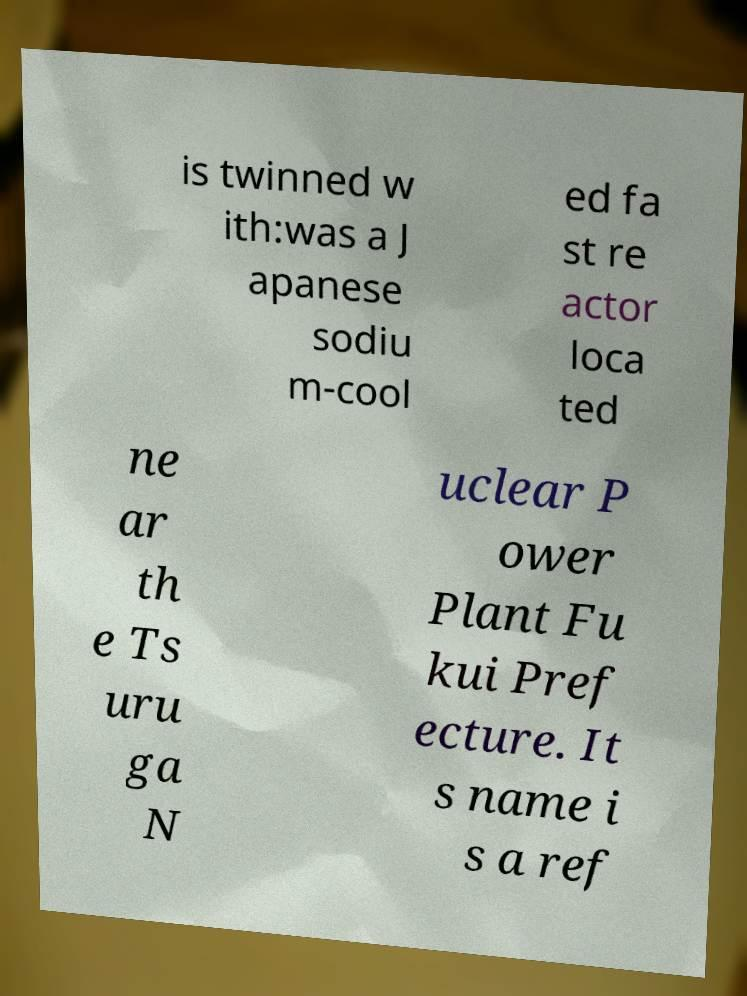Can you read and provide the text displayed in the image?This photo seems to have some interesting text. Can you extract and type it out for me? is twinned w ith:was a J apanese sodiu m-cool ed fa st re actor loca ted ne ar th e Ts uru ga N uclear P ower Plant Fu kui Pref ecture. It s name i s a ref 